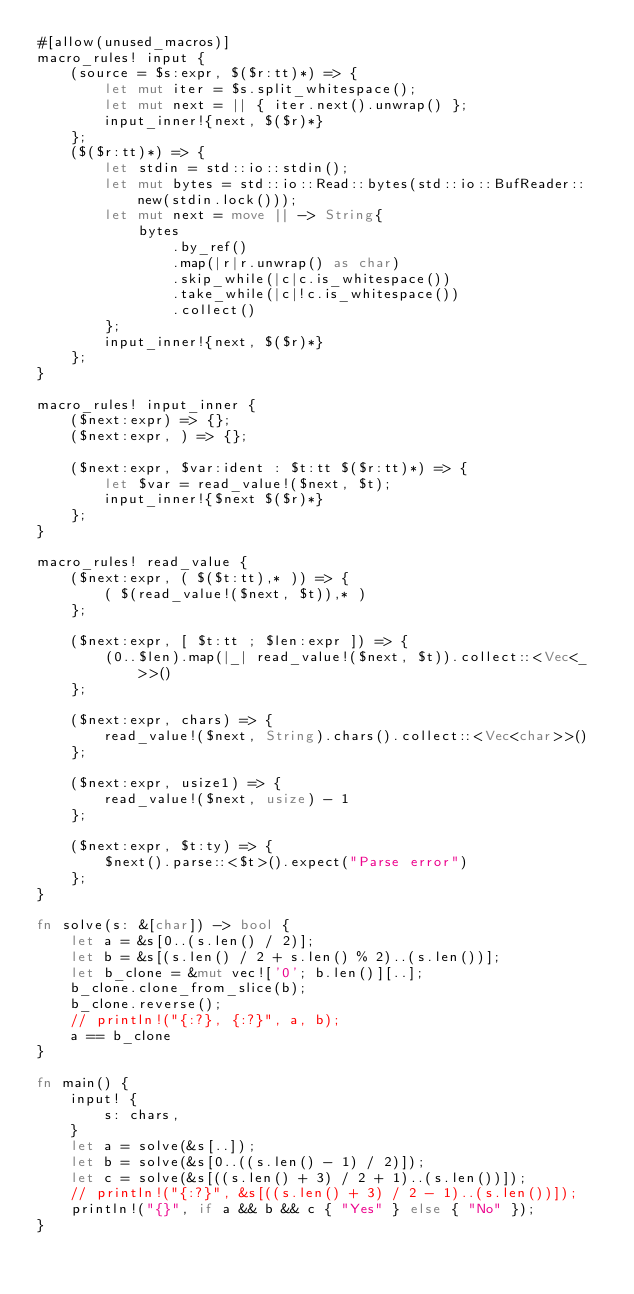Convert code to text. <code><loc_0><loc_0><loc_500><loc_500><_Rust_>#[allow(unused_macros)]
macro_rules! input {
    (source = $s:expr, $($r:tt)*) => {
        let mut iter = $s.split_whitespace();
        let mut next = || { iter.next().unwrap() };
        input_inner!{next, $($r)*}
    };
    ($($r:tt)*) => {
        let stdin = std::io::stdin();
        let mut bytes = std::io::Read::bytes(std::io::BufReader::new(stdin.lock()));
        let mut next = move || -> String{
            bytes
                .by_ref()
                .map(|r|r.unwrap() as char)
                .skip_while(|c|c.is_whitespace())
                .take_while(|c|!c.is_whitespace())
                .collect()
        };
        input_inner!{next, $($r)*}
    };
}

macro_rules! input_inner {
    ($next:expr) => {};
    ($next:expr, ) => {};

    ($next:expr, $var:ident : $t:tt $($r:tt)*) => {
        let $var = read_value!($next, $t);
        input_inner!{$next $($r)*}
    };
}

macro_rules! read_value {
    ($next:expr, ( $($t:tt),* )) => {
        ( $(read_value!($next, $t)),* )
    };

    ($next:expr, [ $t:tt ; $len:expr ]) => {
        (0..$len).map(|_| read_value!($next, $t)).collect::<Vec<_>>()
    };

    ($next:expr, chars) => {
        read_value!($next, String).chars().collect::<Vec<char>>()
    };

    ($next:expr, usize1) => {
        read_value!($next, usize) - 1
    };

    ($next:expr, $t:ty) => {
        $next().parse::<$t>().expect("Parse error")
    };
}

fn solve(s: &[char]) -> bool {
    let a = &s[0..(s.len() / 2)];
    let b = &s[(s.len() / 2 + s.len() % 2)..(s.len())];
    let b_clone = &mut vec!['0'; b.len()][..];
    b_clone.clone_from_slice(b);
    b_clone.reverse();
    // println!("{:?}, {:?}", a, b);
    a == b_clone
}

fn main() {
    input! {
        s: chars,
    }
    let a = solve(&s[..]);
    let b = solve(&s[0..((s.len() - 1) / 2)]);
    let c = solve(&s[((s.len() + 3) / 2 + 1)..(s.len())]);
    // println!("{:?}", &s[((s.len() + 3) / 2 - 1)..(s.len())]);
    println!("{}", if a && b && c { "Yes" } else { "No" });
}</code> 